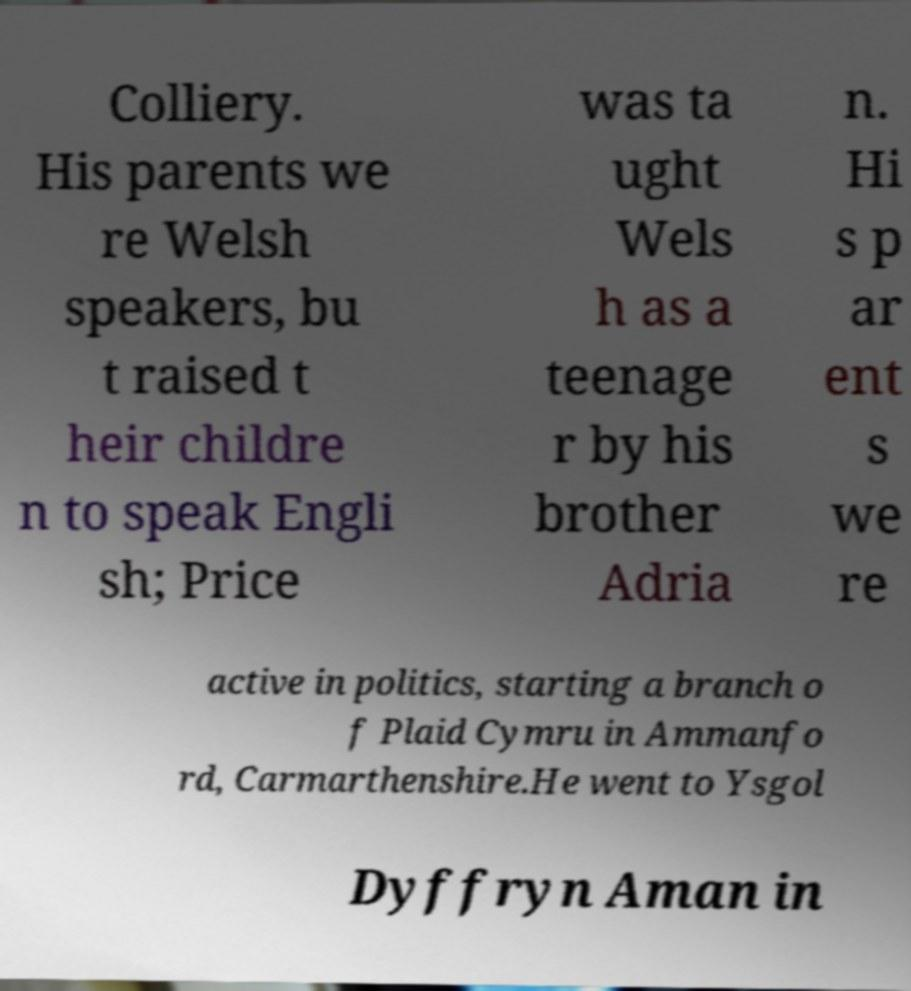There's text embedded in this image that I need extracted. Can you transcribe it verbatim? Colliery. His parents we re Welsh speakers, bu t raised t heir childre n to speak Engli sh; Price was ta ught Wels h as a teenage r by his brother Adria n. Hi s p ar ent s we re active in politics, starting a branch o f Plaid Cymru in Ammanfo rd, Carmarthenshire.He went to Ysgol Dyffryn Aman in 